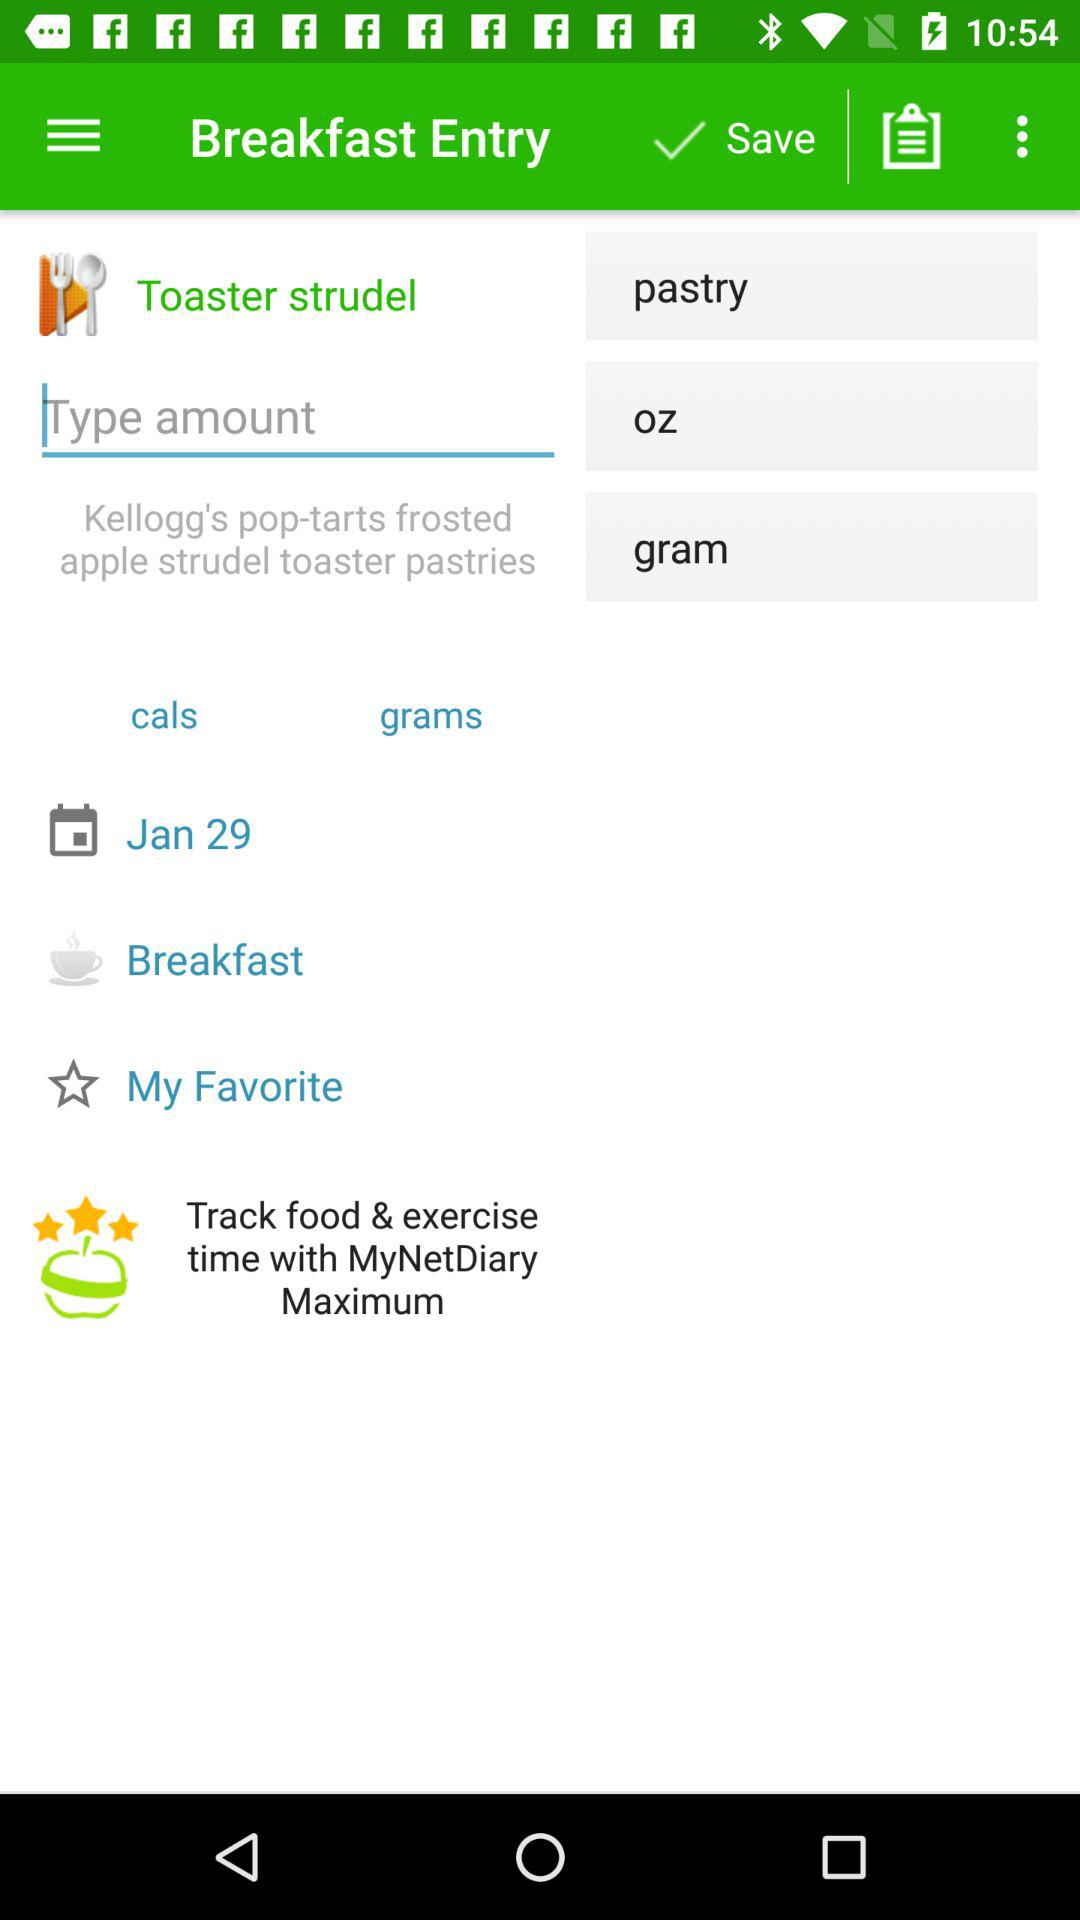What is the date of breakfast? The breakfast date is January 29. 